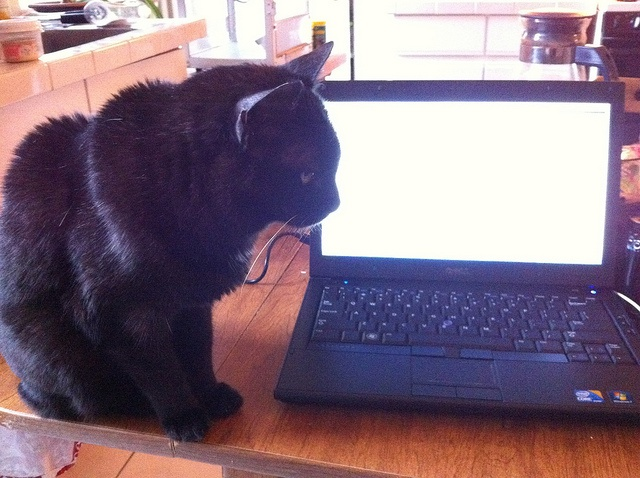Describe the objects in this image and their specific colors. I can see laptop in salmon, ivory, navy, blue, and purple tones, cat in salmon, black, navy, and purple tones, dining table in salmon, brown, and maroon tones, keyboard in salmon, navy, purple, and blue tones, and hair drier in salmon, lightgray, darkgray, and gray tones in this image. 